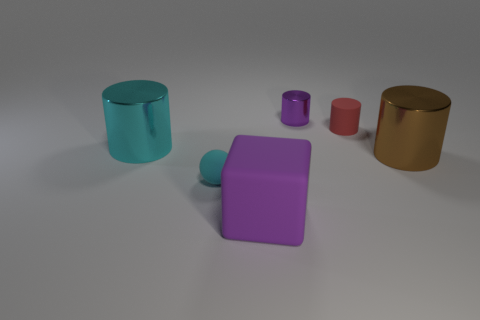Subtract all cyan metal cylinders. How many cylinders are left? 3 Add 1 large blue matte cubes. How many objects exist? 7 Subtract all red cylinders. How many cylinders are left? 3 Subtract 1 cylinders. How many cylinders are left? 3 Subtract all blocks. How many objects are left? 5 Subtract all blue cylinders. Subtract all cyan balls. How many cylinders are left? 4 Subtract all rubber cylinders. Subtract all cyan metal cylinders. How many objects are left? 4 Add 3 tiny purple cylinders. How many tiny purple cylinders are left? 4 Add 6 red objects. How many red objects exist? 7 Subtract 0 cyan cubes. How many objects are left? 6 